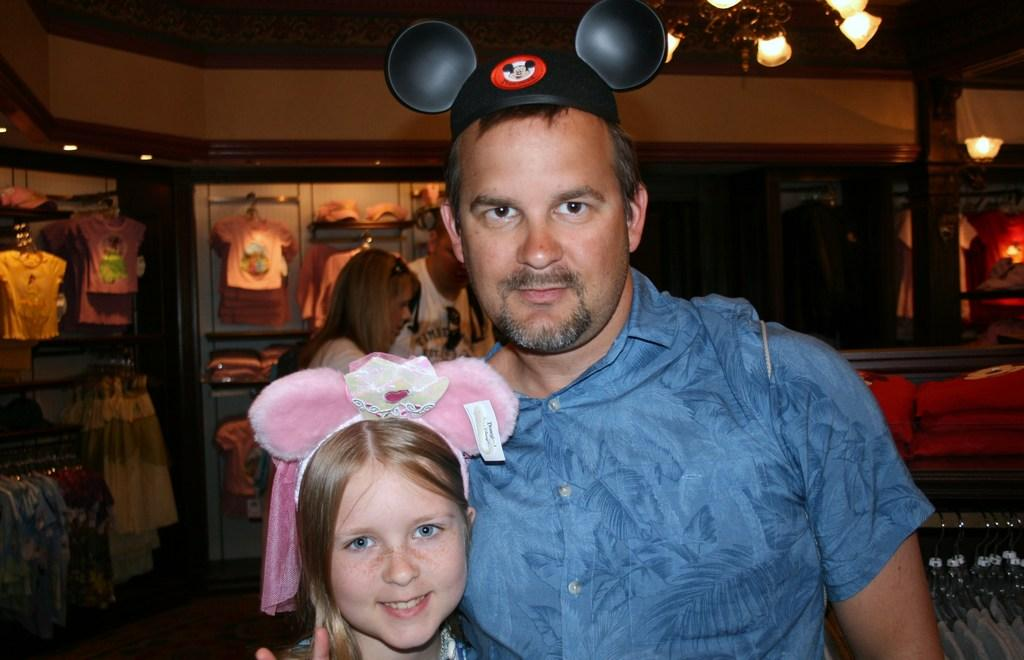What can be observed about the people in the image? There are people standing in the image. Can you describe the clothing of one of the individuals? A man is wearing a cap in the image. What type of items are hanging in the image? There are clothes on hangers in the image. What can be seen illuminating the area in the image? There are lights visible in the image. What type of location might this image depict? The image appears to depict a store. What type of request is the man making to his partner in the image? There is no indication of a request or a partner in the image; it depicts people standing in a store with clothes on hangers and lights visible. 